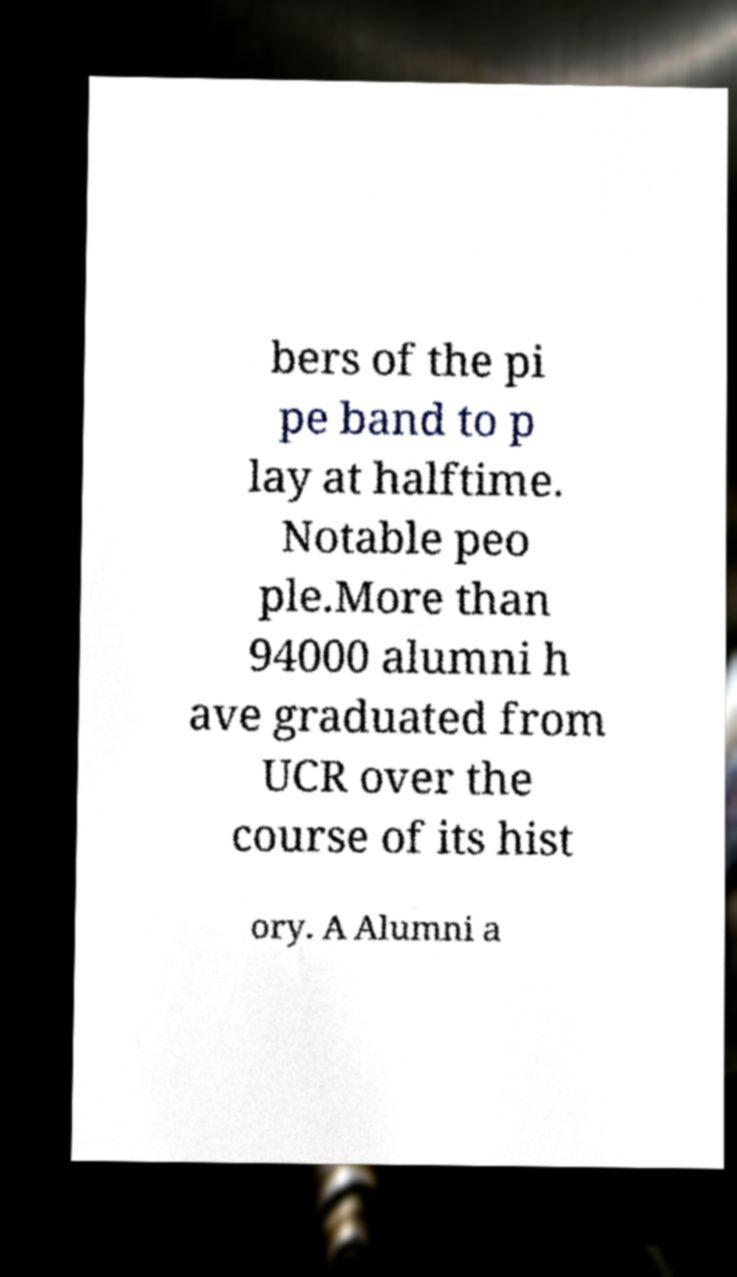Can you read and provide the text displayed in the image?This photo seems to have some interesting text. Can you extract and type it out for me? bers of the pi pe band to p lay at halftime. Notable peo ple.More than 94000 alumni h ave graduated from UCR over the course of its hist ory. A Alumni a 